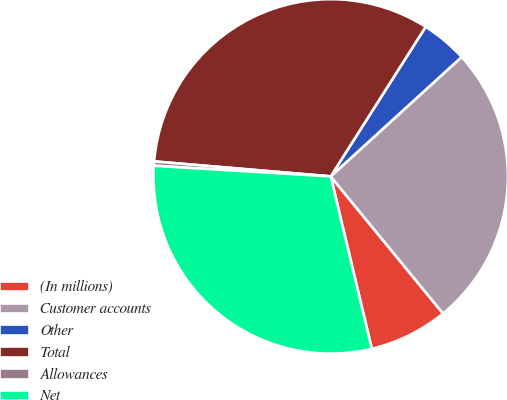<chart> <loc_0><loc_0><loc_500><loc_500><pie_chart><fcel>(In millions)<fcel>Customer accounts<fcel>Other<fcel>Total<fcel>Allowances<fcel>Net<nl><fcel>7.2%<fcel>25.84%<fcel>4.23%<fcel>32.65%<fcel>0.39%<fcel>29.68%<nl></chart> 